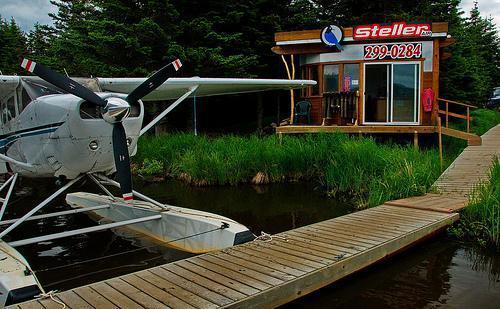How many planes?
Give a very brief answer. 1. 